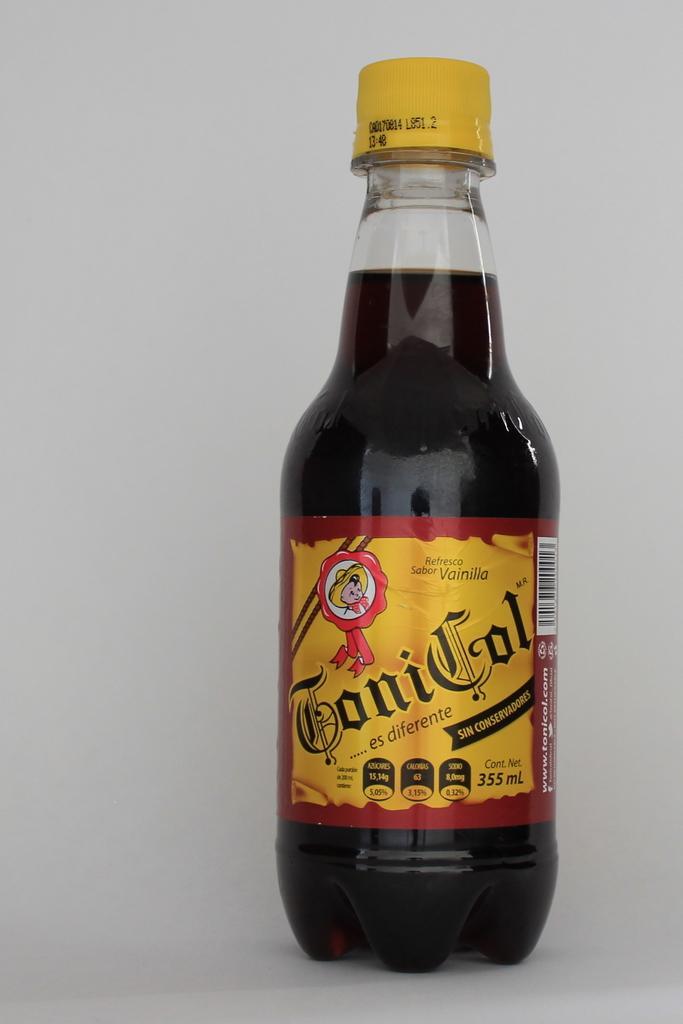Can you describe this image briefly? In this picture i could see a bottle filled with some liquid with yellow color lid on it. It is placed on the countertop. 